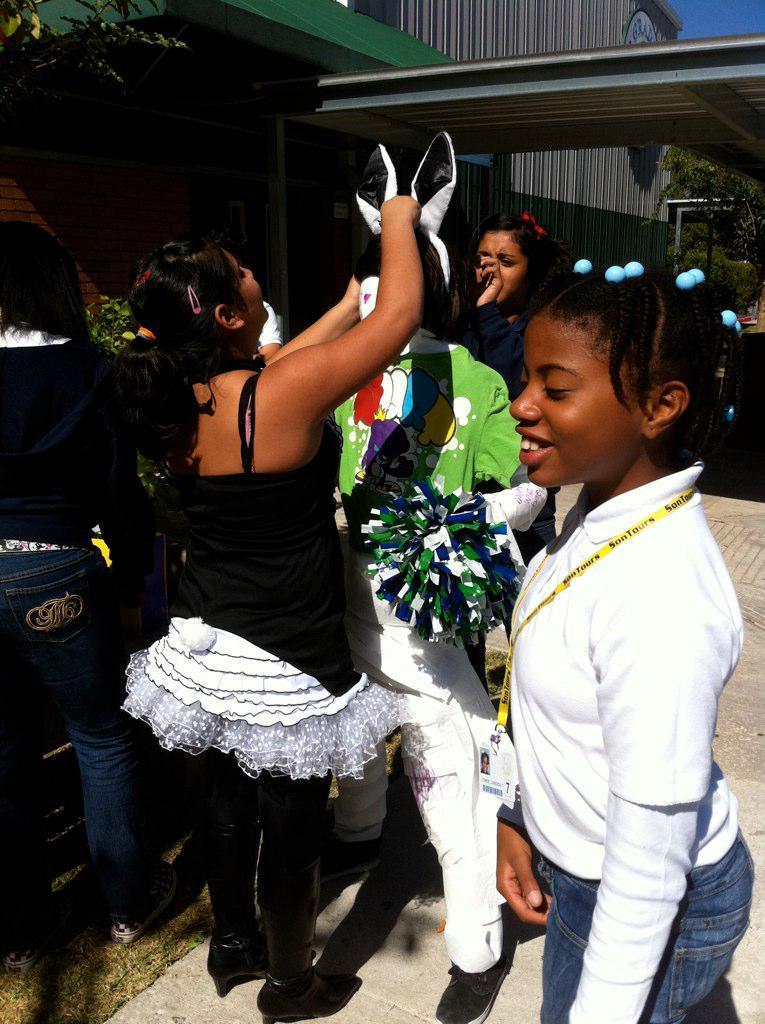In one or two sentences, can you explain what this image depicts? In the center of the image we can see persons standing on the ground. In the background we can see trees, house and sky. 